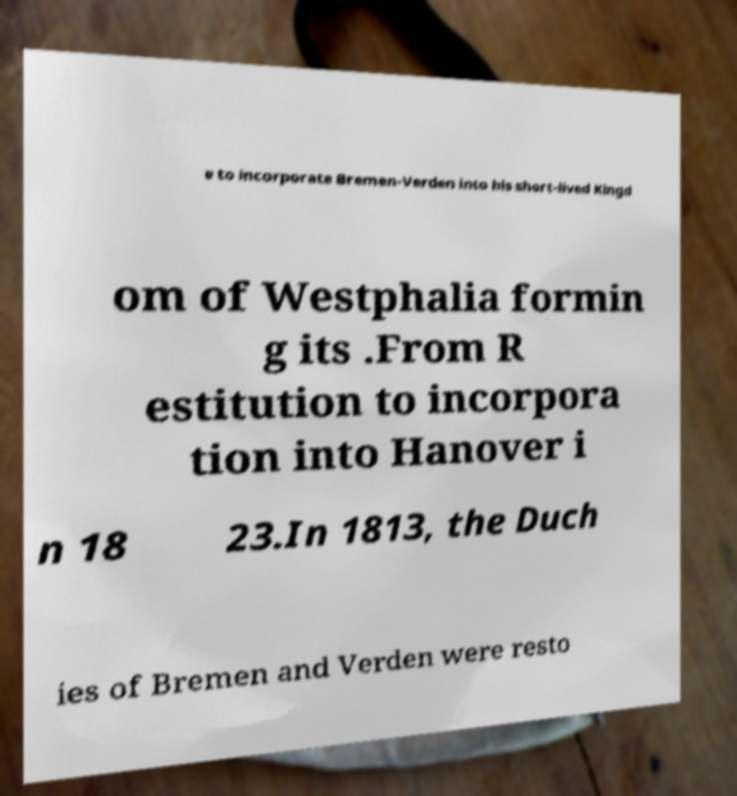Could you assist in decoding the text presented in this image and type it out clearly? e to incorporate Bremen-Verden into his short-lived Kingd om of Westphalia formin g its .From R estitution to incorpora tion into Hanover i n 18 23.In 1813, the Duch ies of Bremen and Verden were resto 